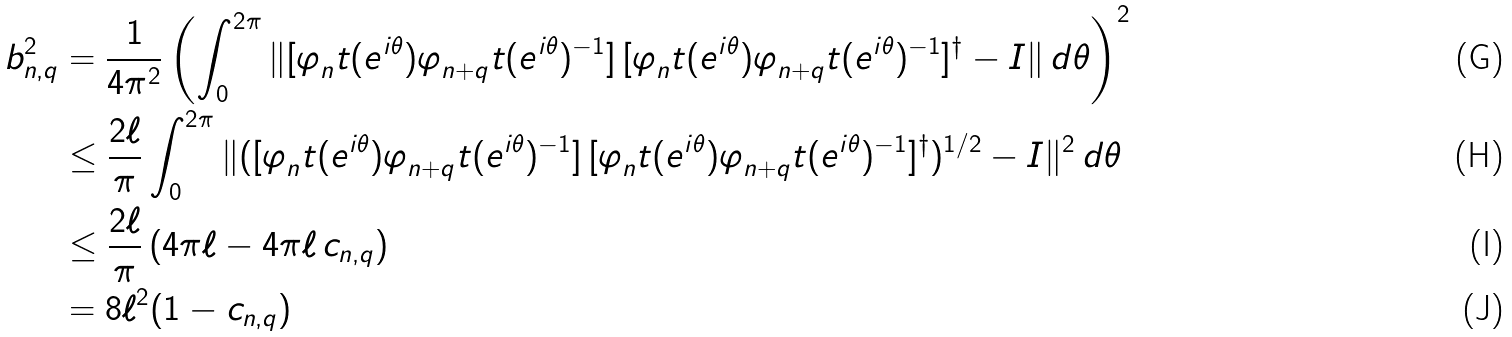<formula> <loc_0><loc_0><loc_500><loc_500>b _ { n , q } ^ { 2 } & = \frac { 1 } { 4 \pi ^ { 2 } } \left ( \int _ { 0 } ^ { 2 \pi } \| [ \varphi _ { n } ^ { \L } t ( e ^ { i \theta } ) \varphi _ { n + q } ^ { \L } t ( e ^ { i \theta } ) ^ { - 1 } ] \, [ \varphi _ { n } ^ { \L } t ( e ^ { i \theta } ) \varphi _ { n + q } ^ { \L } t ( e ^ { i \theta } ) ^ { - 1 } ] ^ { \dagger } - I \| \, d \theta \right ) ^ { 2 } \\ & \leq \frac { 2 \ell } { \pi } \int _ { 0 } ^ { 2 \pi } \| ( [ \varphi _ { n } ^ { \L } t ( e ^ { i \theta } ) \varphi _ { n + q } ^ { \L } t ( e ^ { i \theta } ) ^ { - 1 } ] \, [ \varphi _ { n } ^ { \L } t ( e ^ { i \theta } ) \varphi _ { n + q } ^ { \L } t ( e ^ { i \theta } ) ^ { - 1 } ] ^ { \dagger } ) ^ { 1 / 2 } - I \| ^ { 2 } \, d \theta \\ & \leq \frac { 2 \ell } { \pi } \, ( 4 \pi \ell - 4 \pi \ell \, c _ { n , q } ) \\ & = 8 \ell ^ { 2 } ( 1 - c _ { n , q } )</formula> 